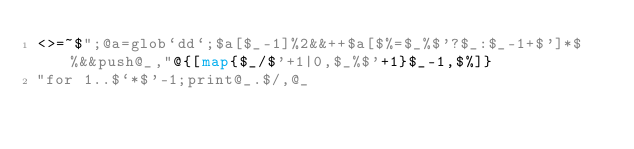<code> <loc_0><loc_0><loc_500><loc_500><_Perl_><>=~$";@a=glob`dd`;$a[$_-1]%2&&++$a[$%=$_%$'?$_:$_-1+$']*$%&&push@_,"@{[map{$_/$'+1|0,$_%$'+1}$_-1,$%]}
"for 1..$`*$'-1;print@_.$/,@_</code> 